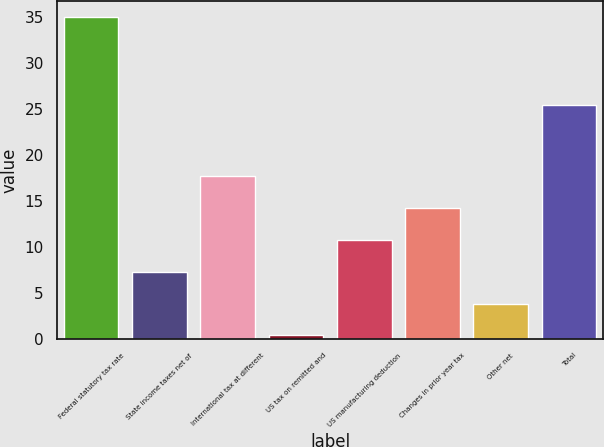Convert chart to OTSL. <chart><loc_0><loc_0><loc_500><loc_500><bar_chart><fcel>Federal statutory tax rate<fcel>State income taxes net of<fcel>International tax at different<fcel>US tax on remitted and<fcel>US manufacturing deduction<fcel>Changes in prior year tax<fcel>Other net<fcel>Total<nl><fcel>35<fcel>7.32<fcel>17.7<fcel>0.4<fcel>10.78<fcel>14.24<fcel>3.86<fcel>25.4<nl></chart> 